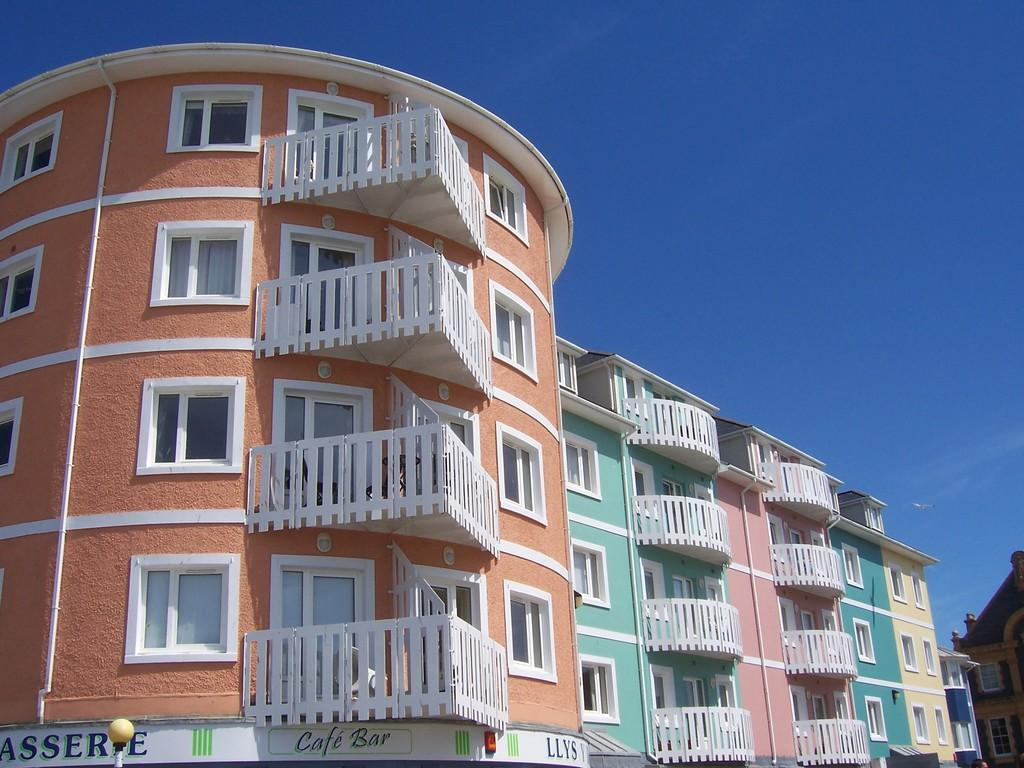What type of structures can be seen in the image? There are buildings in the image. What can be seen in the sky in the image? Clouds are visible at the top of the image. What else is visible in the sky in the image? The sky is visible in the image. How many beggars are visible in the image? There are no beggars present in the image. What type of boundary can be seen in the image? There is no boundary or harmony present in the image; it features buildings, clouds, and the sky. 